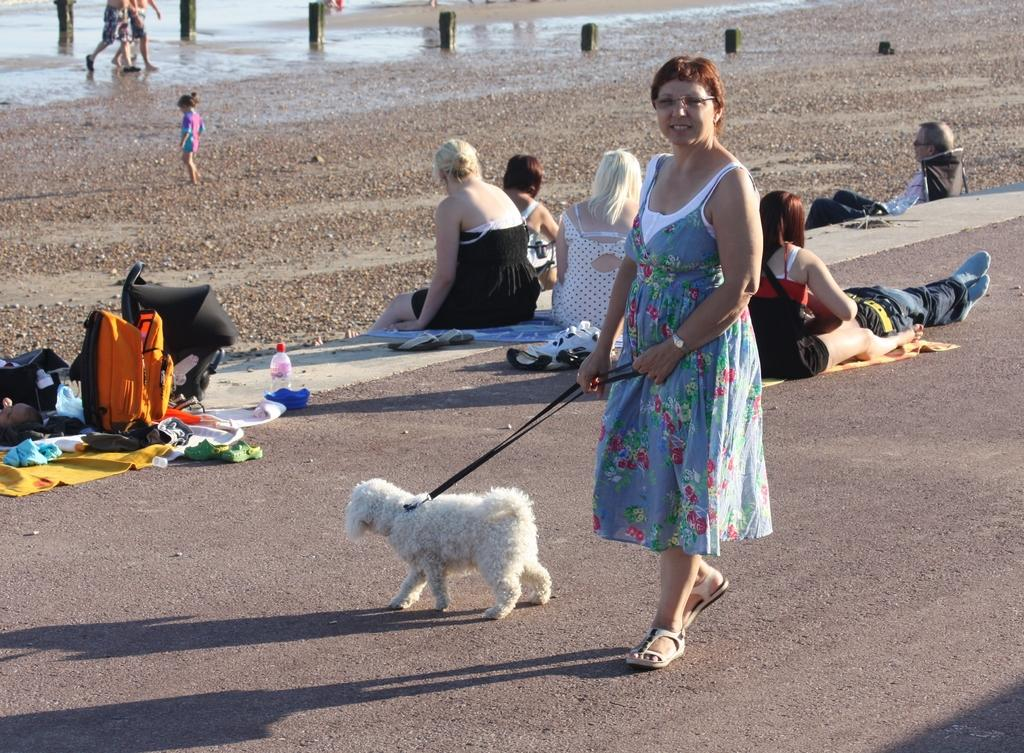Who is the main subject in the image? There is a woman in the image. What is the woman doing in the image? The woman is carrying a dog. What else can be seen in the image besides the woman and the dog? There are people sitting on the road in the image. What can be seen in the background of the image? There are bags, bottles, and water visible in the background of the image. What type of teeth can be seen in the image? There are no teeth visible in the image. Where is the owl located in the image? There is no owl present in the image. 